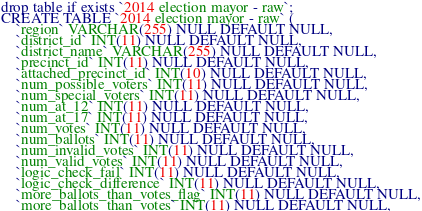Convert code to text. <code><loc_0><loc_0><loc_500><loc_500><_SQL_>drop table if exists `2014 election mayor - raw`;
CREATE TABLE `2014 election mayor - raw` (
	`region` VARCHAR(255) NULL DEFAULT NULL,
	`district_id` INT(11) NULL DEFAULT NULL,
	`district_name` VARCHAR(255) NULL DEFAULT NULL,
	`precinct_id` INT(11) NULL DEFAULT NULL,
	`attached_precinct_id` INT(10) NULL DEFAULT NULL,
	`num_possible_voters` INT(11) NULL DEFAULT NULL,
	`num_special_voters` INT(11) NULL DEFAULT NULL,
	`num_at_12` INT(11) NULL DEFAULT NULL,
	`num_at_17` INT(11) NULL DEFAULT NULL,
	`num_votes` INT(11) NULL DEFAULT NULL,
	`num_ballots` INT(11) NULL DEFAULT NULL,
	`num_invalid_votes` INT(11) NULL DEFAULT NULL,
	`num_valid_votes` INT(11) NULL DEFAULT NULL,
	`logic_check_fail` INT(11) NULL DEFAULT NULL,
	`logic_check_difference` INT(11) NULL DEFAULT NULL,
	`more_ballots_than_votes_flag` INT(11) NULL DEFAULT NULL,
	`more_ballots_than_votes` INT(11) NULL DEFAULT NULL,</code> 